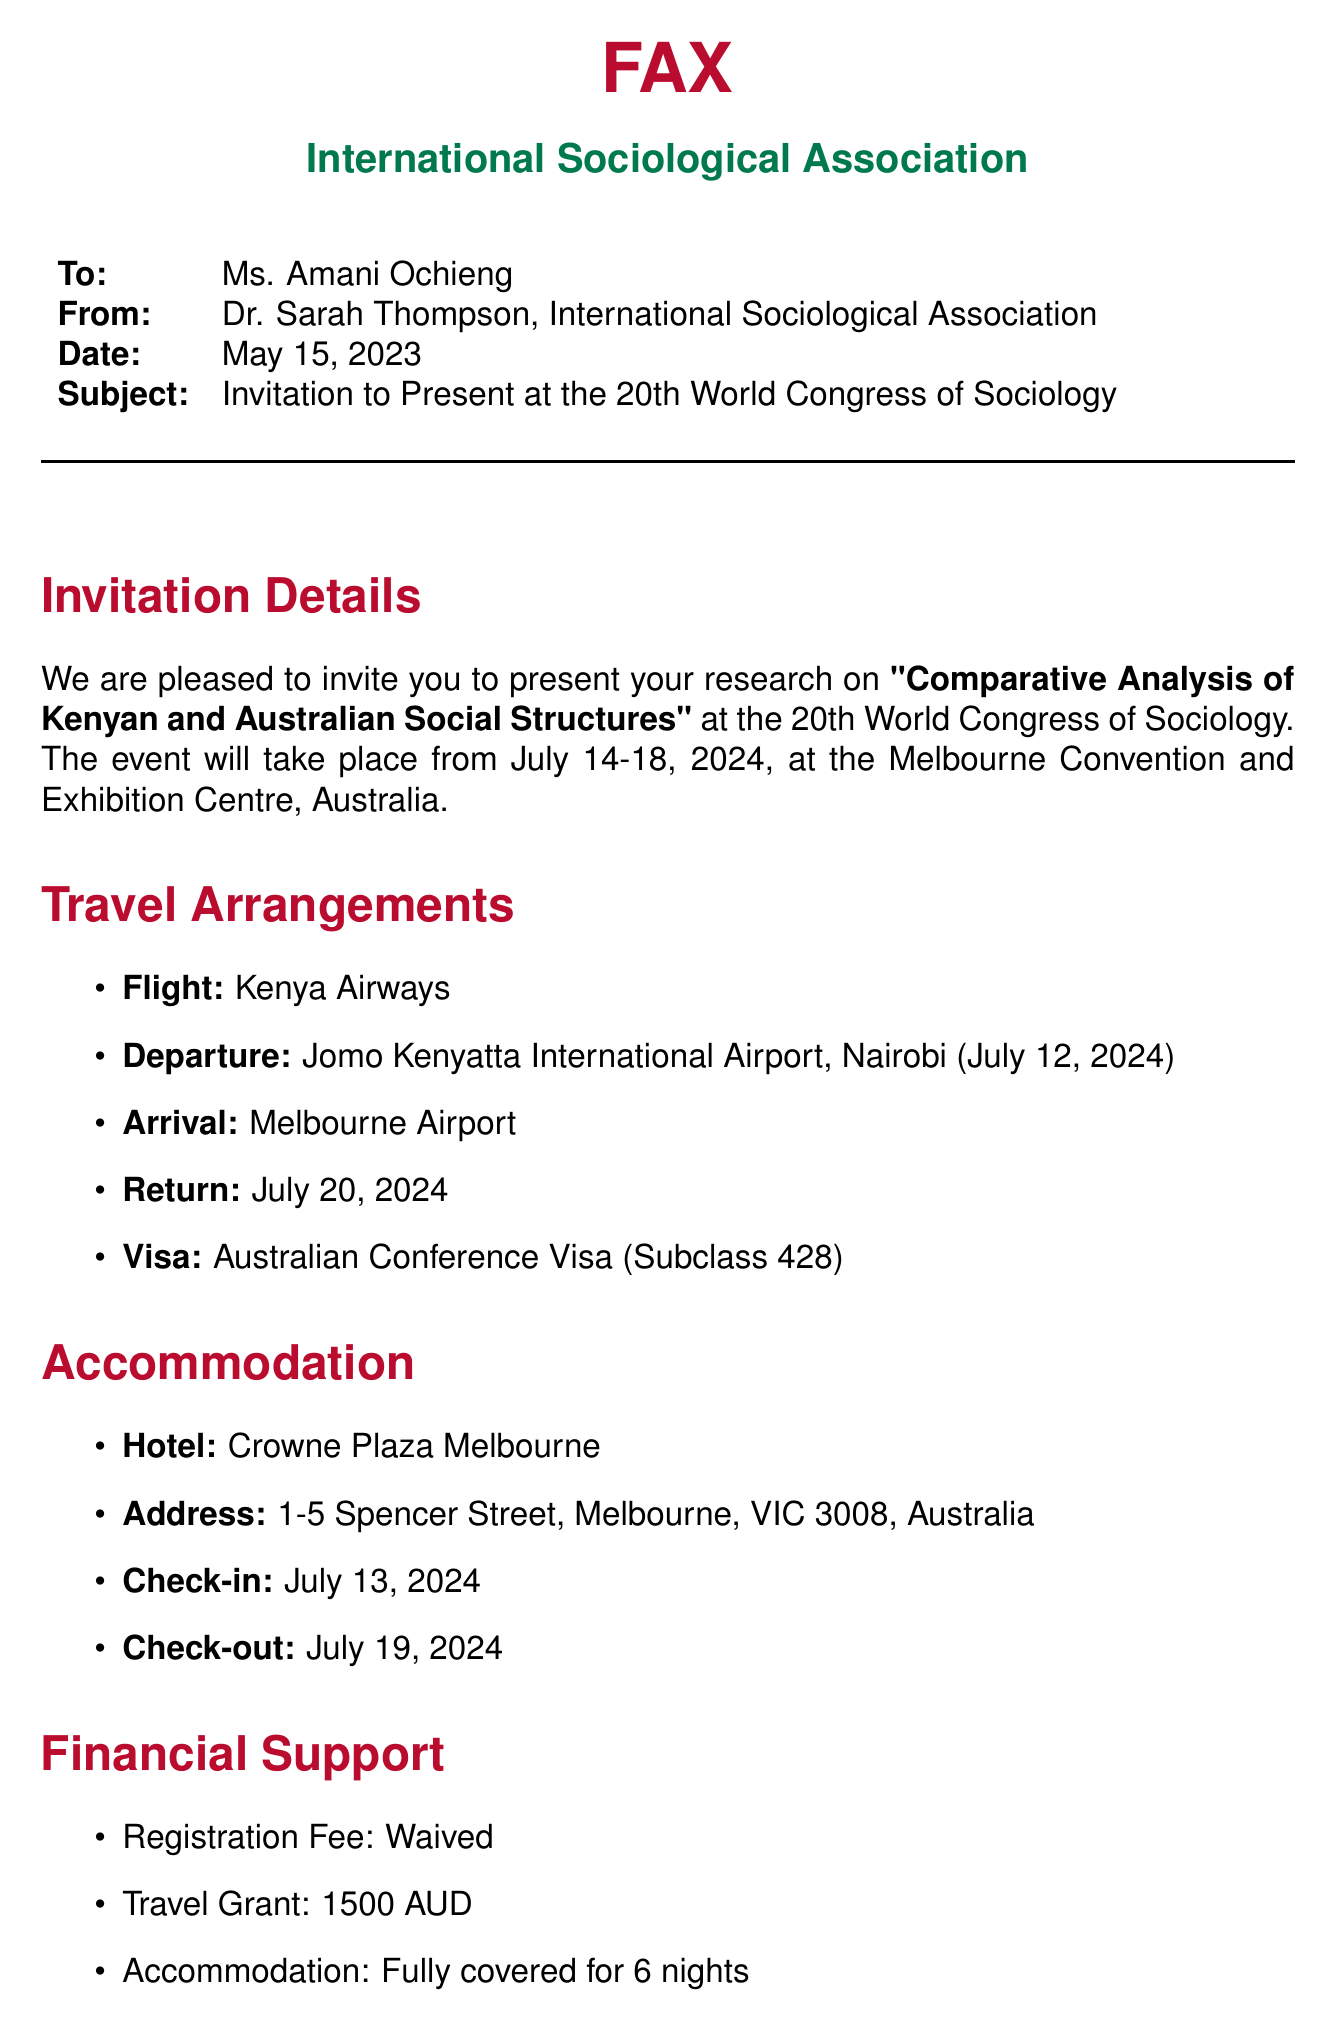What is the subject of the fax? The subject is stated in the document and refers to the purpose of the communication.
Answer: Invitation to Present at the 20th World Congress of Sociology What are the dates of the conference? The dates for the event are specified in the document under the invitation details section.
Answer: July 14-18, 2024 What is the name of the hotel for accommodation? The document outlines the accommodation details, including the name of the hotel.
Answer: Crowne Plaza Melbourne When is the check-out date from the hotel? This information is provided in the accommodation section of the document.
Answer: July 19, 2024 What is the travel grant amount? The financial support section mentions the specific amount provided for the travel grant.
Answer: 1500 AUD What is the departure airport? The document specifies the airport from which the flight will depart.
Answer: Jomo Kenyatta International Airport, Nairobi How many nights will accommodation be covered? This is mentioned in the financial support section regarding the accommodation details.
Answer: 6 nights What type of visa is required for the conference? The document states the specific type of visa needed for attending the conference.
Answer: Australian Conference Visa (Subclass 428) What is the return date of the flight? The return date for the flight is explicitly detailed in the travel arrangements section.
Answer: July 20, 2024 